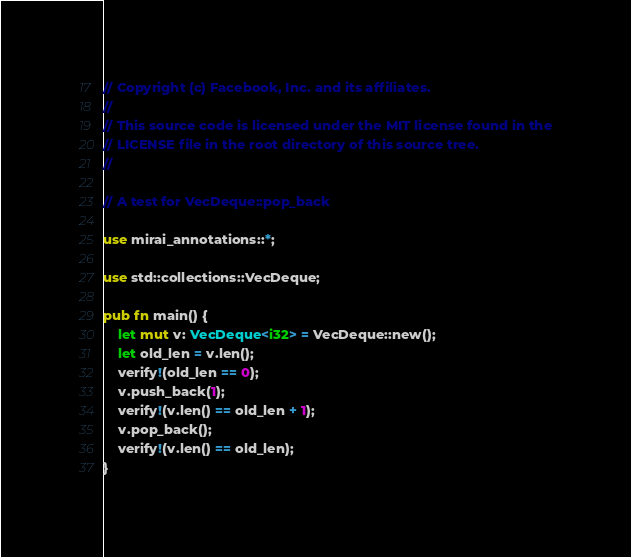Convert code to text. <code><loc_0><loc_0><loc_500><loc_500><_Rust_>// Copyright (c) Facebook, Inc. and its affiliates.
//
// This source code is licensed under the MIT license found in the
// LICENSE file in the root directory of this source tree.
//

// A test for VecDeque::pop_back

use mirai_annotations::*;

use std::collections::VecDeque;

pub fn main() {
    let mut v: VecDeque<i32> = VecDeque::new();
    let old_len = v.len();
    verify!(old_len == 0);
    v.push_back(1);
    verify!(v.len() == old_len + 1);
    v.pop_back();
    verify!(v.len() == old_len);
}
</code> 